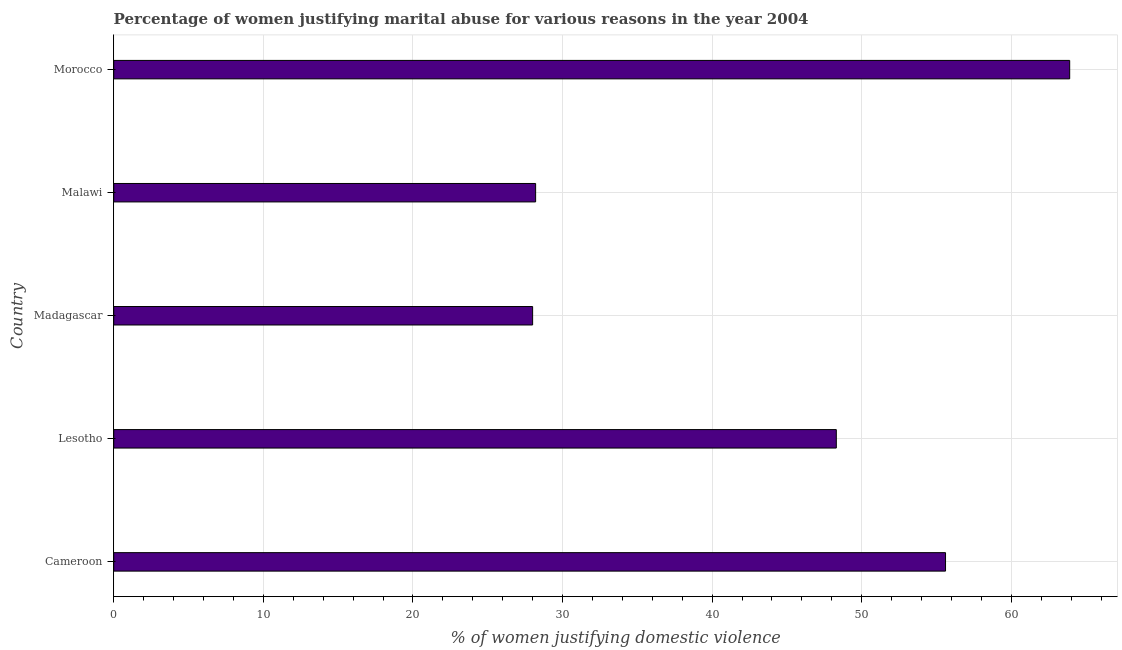Does the graph contain grids?
Offer a very short reply. Yes. What is the title of the graph?
Offer a terse response. Percentage of women justifying marital abuse for various reasons in the year 2004. What is the label or title of the X-axis?
Ensure brevity in your answer.  % of women justifying domestic violence. What is the label or title of the Y-axis?
Your answer should be very brief. Country. What is the percentage of women justifying marital abuse in Lesotho?
Offer a terse response. 48.3. Across all countries, what is the maximum percentage of women justifying marital abuse?
Provide a succinct answer. 63.9. Across all countries, what is the minimum percentage of women justifying marital abuse?
Ensure brevity in your answer.  28. In which country was the percentage of women justifying marital abuse maximum?
Offer a terse response. Morocco. In which country was the percentage of women justifying marital abuse minimum?
Offer a very short reply. Madagascar. What is the sum of the percentage of women justifying marital abuse?
Your answer should be very brief. 224. What is the difference between the percentage of women justifying marital abuse in Lesotho and Morocco?
Ensure brevity in your answer.  -15.6. What is the average percentage of women justifying marital abuse per country?
Make the answer very short. 44.8. What is the median percentage of women justifying marital abuse?
Offer a very short reply. 48.3. What is the ratio of the percentage of women justifying marital abuse in Lesotho to that in Malawi?
Offer a very short reply. 1.71. Is the difference between the percentage of women justifying marital abuse in Malawi and Morocco greater than the difference between any two countries?
Provide a short and direct response. No. What is the difference between the highest and the lowest percentage of women justifying marital abuse?
Keep it short and to the point. 35.9. What is the difference between two consecutive major ticks on the X-axis?
Your answer should be compact. 10. What is the % of women justifying domestic violence in Cameroon?
Keep it short and to the point. 55.6. What is the % of women justifying domestic violence in Lesotho?
Your answer should be compact. 48.3. What is the % of women justifying domestic violence of Malawi?
Ensure brevity in your answer.  28.2. What is the % of women justifying domestic violence of Morocco?
Offer a very short reply. 63.9. What is the difference between the % of women justifying domestic violence in Cameroon and Lesotho?
Your response must be concise. 7.3. What is the difference between the % of women justifying domestic violence in Cameroon and Madagascar?
Make the answer very short. 27.6. What is the difference between the % of women justifying domestic violence in Cameroon and Malawi?
Give a very brief answer. 27.4. What is the difference between the % of women justifying domestic violence in Lesotho and Madagascar?
Your answer should be compact. 20.3. What is the difference between the % of women justifying domestic violence in Lesotho and Malawi?
Your answer should be compact. 20.1. What is the difference between the % of women justifying domestic violence in Lesotho and Morocco?
Keep it short and to the point. -15.6. What is the difference between the % of women justifying domestic violence in Madagascar and Malawi?
Give a very brief answer. -0.2. What is the difference between the % of women justifying domestic violence in Madagascar and Morocco?
Give a very brief answer. -35.9. What is the difference between the % of women justifying domestic violence in Malawi and Morocco?
Give a very brief answer. -35.7. What is the ratio of the % of women justifying domestic violence in Cameroon to that in Lesotho?
Your answer should be very brief. 1.15. What is the ratio of the % of women justifying domestic violence in Cameroon to that in Madagascar?
Offer a terse response. 1.99. What is the ratio of the % of women justifying domestic violence in Cameroon to that in Malawi?
Give a very brief answer. 1.97. What is the ratio of the % of women justifying domestic violence in Cameroon to that in Morocco?
Your response must be concise. 0.87. What is the ratio of the % of women justifying domestic violence in Lesotho to that in Madagascar?
Provide a short and direct response. 1.73. What is the ratio of the % of women justifying domestic violence in Lesotho to that in Malawi?
Make the answer very short. 1.71. What is the ratio of the % of women justifying domestic violence in Lesotho to that in Morocco?
Your answer should be compact. 0.76. What is the ratio of the % of women justifying domestic violence in Madagascar to that in Malawi?
Keep it short and to the point. 0.99. What is the ratio of the % of women justifying domestic violence in Madagascar to that in Morocco?
Provide a succinct answer. 0.44. What is the ratio of the % of women justifying domestic violence in Malawi to that in Morocco?
Your answer should be very brief. 0.44. 